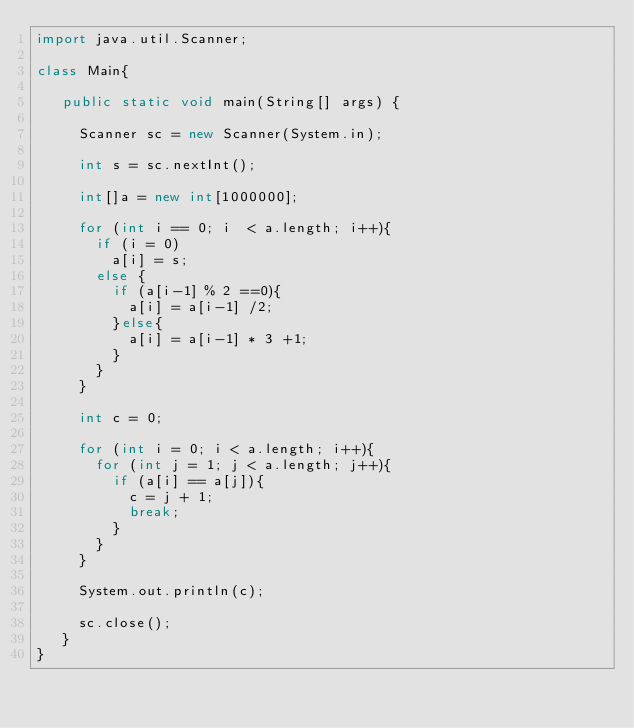<code> <loc_0><loc_0><loc_500><loc_500><_Java_>import java.util.Scanner;

class Main{
  
   public static void main(String[] args) {
     
     Scanner sc = new Scanner(System.in);
     
     int s = sc.nextInt();
     
     int[]a = new int[1000000];
     
     for (int i == 0; i  < a.length; i++){
       if (i = 0)
         a[i] = s;
       else {
         if (a[i-1] % 2 ==0){
           a[i] = a[i-1] /2;
         }else{
           a[i] = a[i-1] * 3 +1;
         }
       }
     }
     
     int c = 0;
     
     for (int i = 0; i < a.length; i++){
       for (int j = 1; j < a.length; j++){
         if (a[i] == a[j]){
           c = j + 1;
           break;
         }
       }
     }
     
     System.out.println(c);
     
     sc.close();
   }
}</code> 